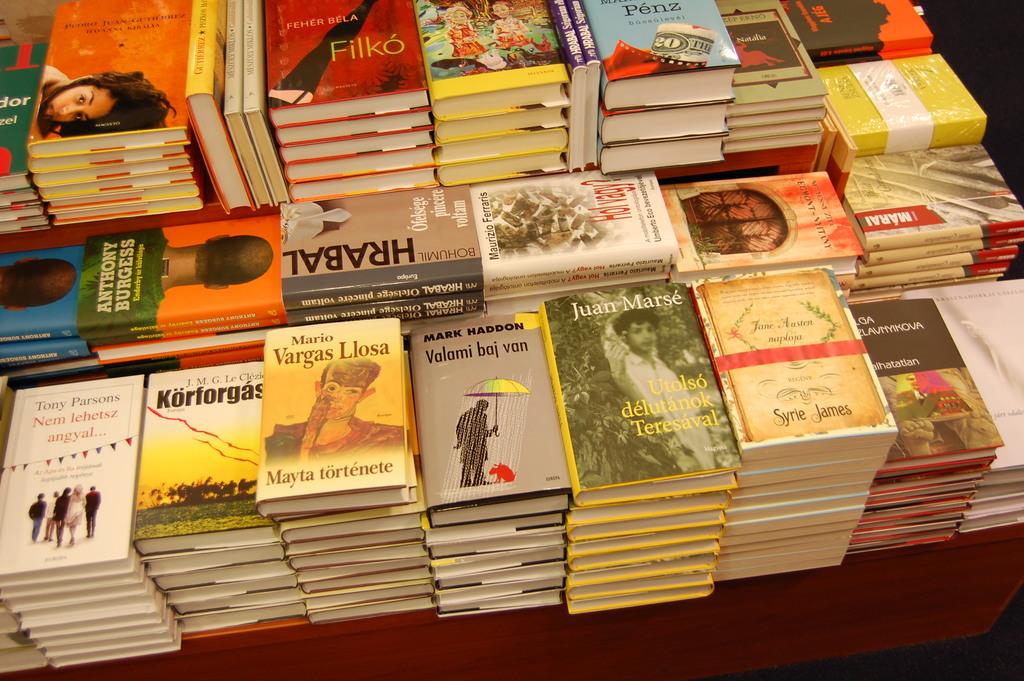Who is the author of the book filko?
Give a very brief answer. Unanswerable. What is the middle book title?
Make the answer very short. Hrabal. 